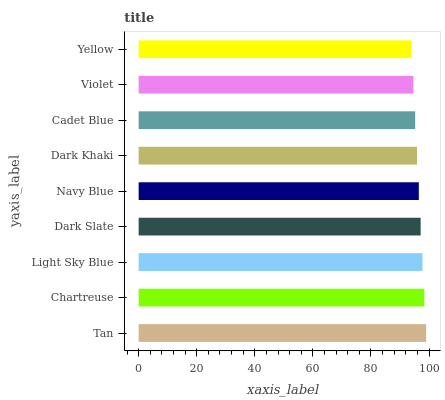Is Yellow the minimum?
Answer yes or no. Yes. Is Tan the maximum?
Answer yes or no. Yes. Is Chartreuse the minimum?
Answer yes or no. No. Is Chartreuse the maximum?
Answer yes or no. No. Is Tan greater than Chartreuse?
Answer yes or no. Yes. Is Chartreuse less than Tan?
Answer yes or no. Yes. Is Chartreuse greater than Tan?
Answer yes or no. No. Is Tan less than Chartreuse?
Answer yes or no. No. Is Navy Blue the high median?
Answer yes or no. Yes. Is Navy Blue the low median?
Answer yes or no. Yes. Is Chartreuse the high median?
Answer yes or no. No. Is Dark Khaki the low median?
Answer yes or no. No. 